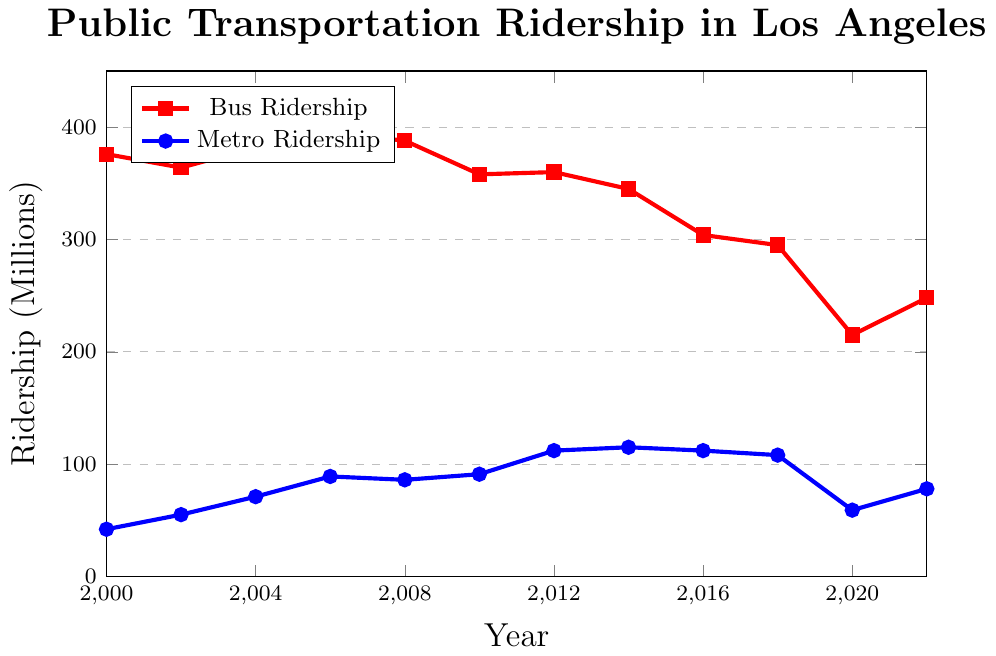What were the bus and metro riderships in 2000? Looking at the x-axis for the year 2000 and checking the corresponding y-values for each line, we see the red line (bus) is at 376 million and the blue line (metro) is at 42 million.
Answer: Bus: 376 million, Metro: 42 million In which year did metro ridership first surpass 100 million? Following the blue line upwards, we see it first crosses the 100 million mark on the y-axis in 2012.
Answer: 2012 What is the difference in bus ridership between 2000 and 2022? From the graph, the bus ridership in 2000 is 376 million and in 2022 is 248 million. The difference is 376 - 248 = 128 million.
Answer: 128 million Compare bus and metro ridership trends between 2010 and 2014. Observing the two lines between 2010 and 2014, the bus ridership (red line) decreases from 358 million to 345 million, while metro ridership (blue line) increases from 91 million to 115 million. This indicates a decline in bus ridership and an increase in metro ridership.
Answer: Bus ↓, Metro ↑ What was the peak bus ridership between 2000 and 2022, and in which year did it occur? The peak of the red line (bus) is highest around 2006 at 395 million.
Answer: 395 million, 2006 How did bus and metro ridership change from 2018 to 2020? From 2018 to 2020, the red line (bus) drops from 295 million to 215 million, and the blue line (metro) drops from 108 million to 59 million. Thus, both riderships decline.
Answer: Both decline Which year had the lowest metro ridership, and what was the ridership? The lowest point of the blue line (metro) is in 2000 with a ridership of 42 million.
Answer: 2000, 42 million What is the combined ridership of bus and metro in 2016? The graph shows bus ridership in 2016 is 304 million and metro is 112 million. Combining them: 304 + 112 = 416 million.
Answer: 416 million How many years did metro ridership exceed 100 million? Observing the blue line, it surpasses 100 million from 2012 to 2018, covering a total of 7 years (2012, 2014, 2016, 2018).
Answer: 7 years Between 2000 and 2022, in which year did bus ridership experience the most significant drop? The most significant drop in the red line (bus) occurs between 2018 (295 million) and 2020 (215 million).
Answer: Between 2018 and 2020 